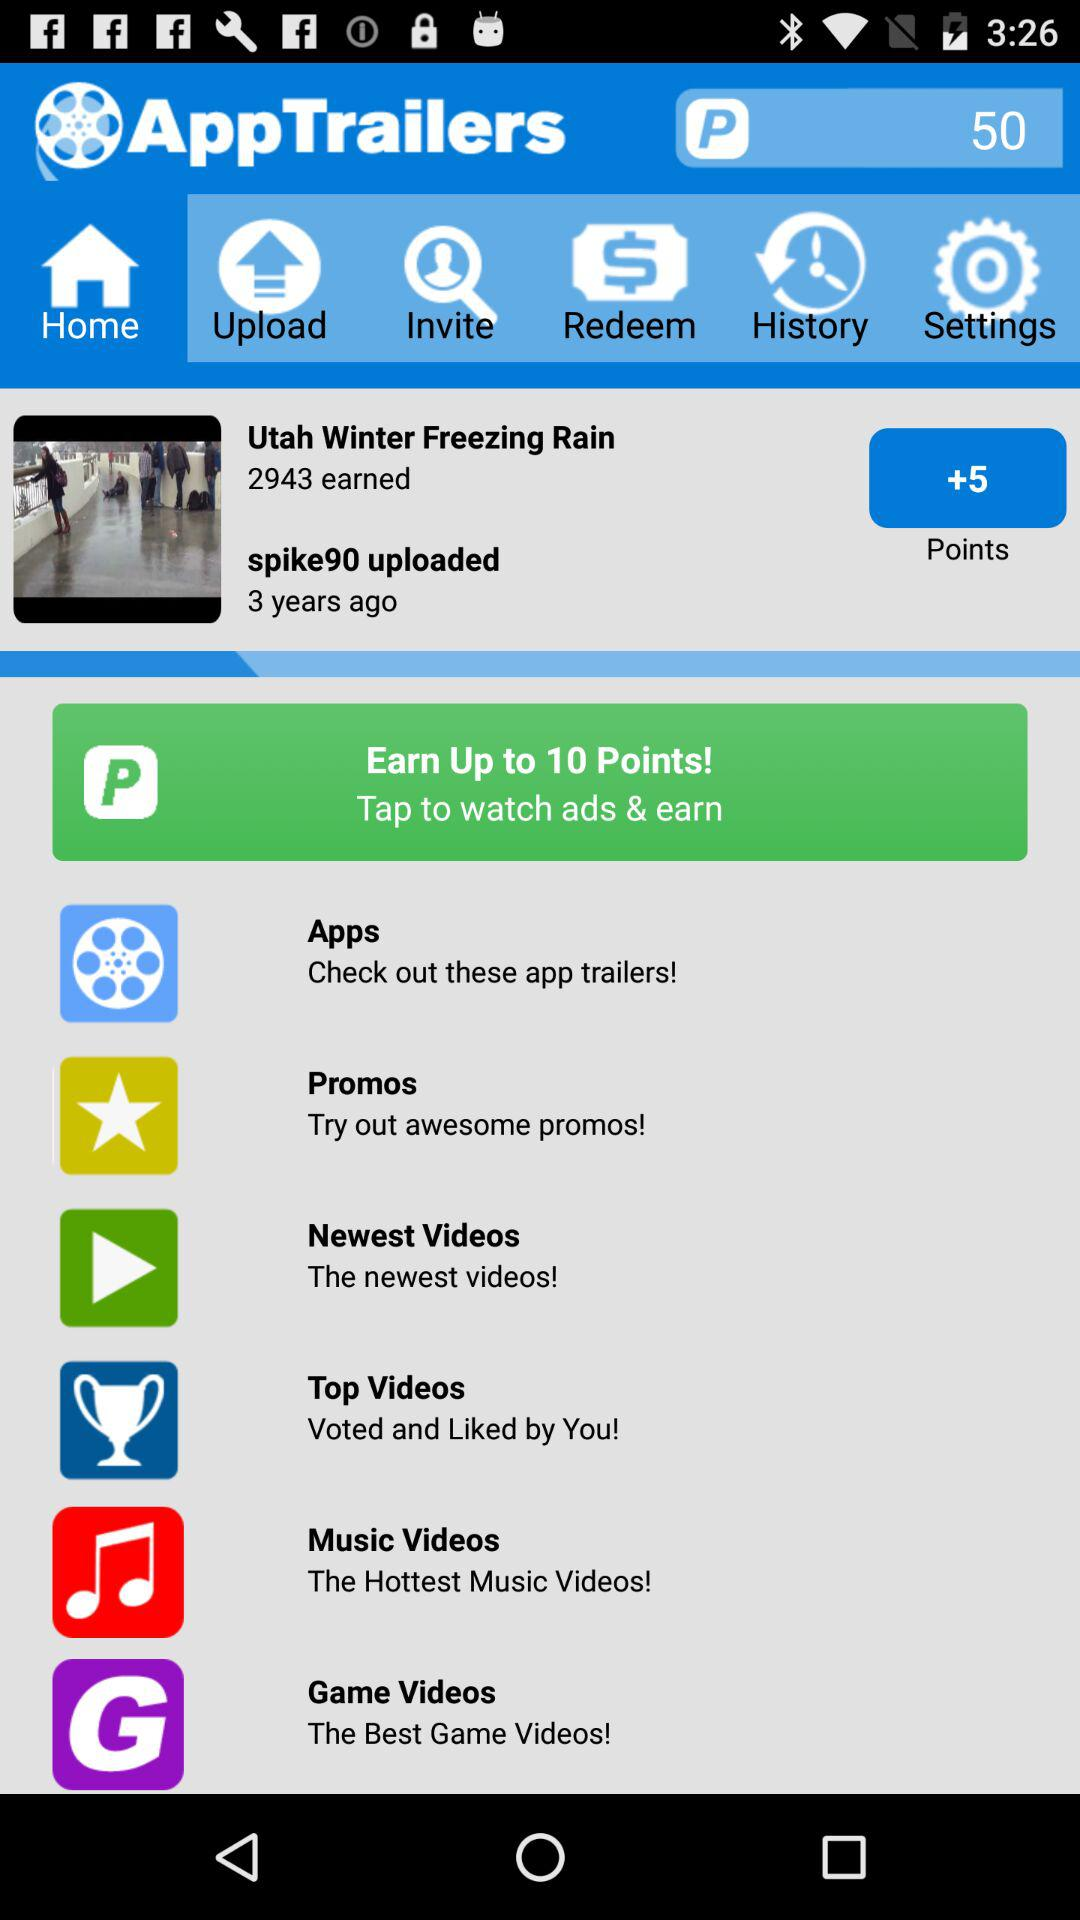How can we earn up to 10 points? You can earn points by tapping to watch ads. 